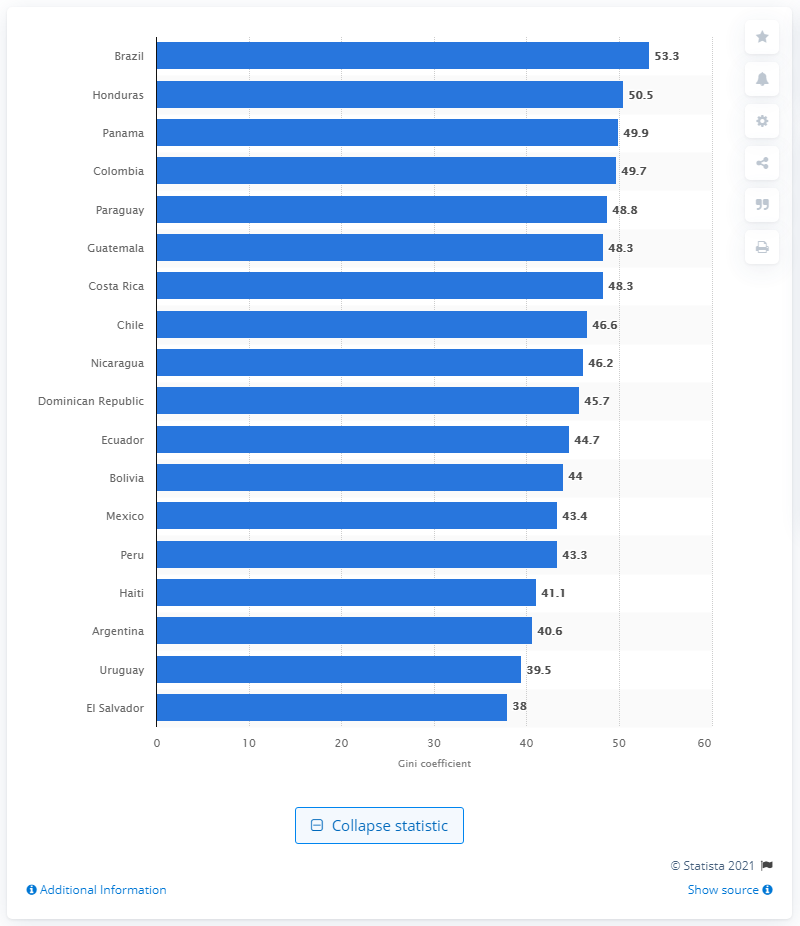Point out several critical features in this image. According to the data, the Gini coefficient for Brazil was 53.3, indicating a moderate level of income inequality in the country. Honduras had the highest Gini coefficient among all countries in the world. El Salvador had the lowest Gini coefficient among all countries in the world. 